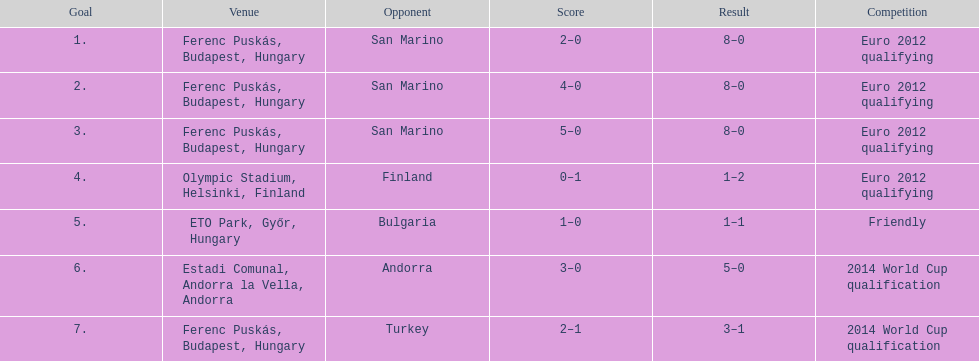In what year was szalai's first international goal? 2010. 